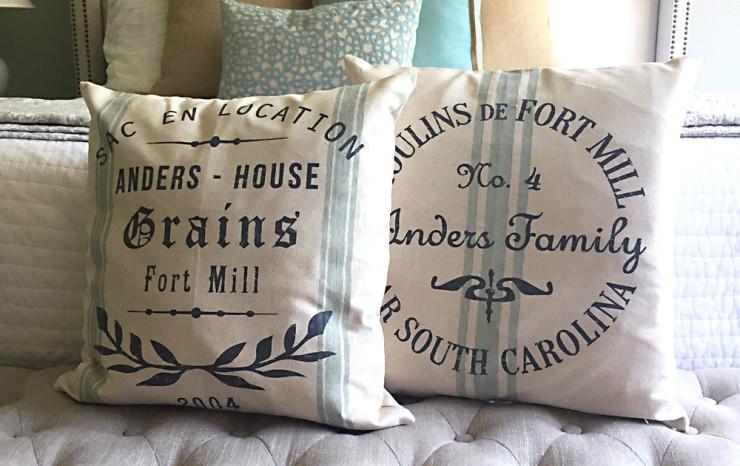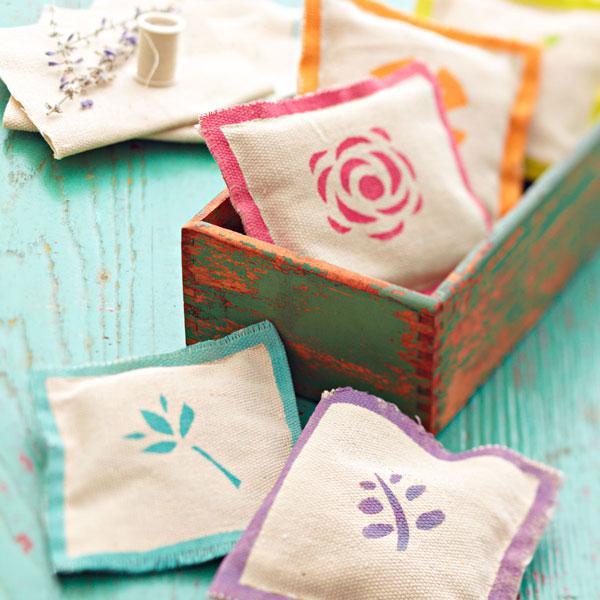The first image is the image on the left, the second image is the image on the right. Assess this claim about the two images: "All images include at least one pillow with text on it, and one image also includes two striped pillows.". Correct or not? Answer yes or no. No. The first image is the image on the left, the second image is the image on the right. Examine the images to the left and right. Is the description "There are at least 7 pillows." accurate? Answer yes or no. Yes. 